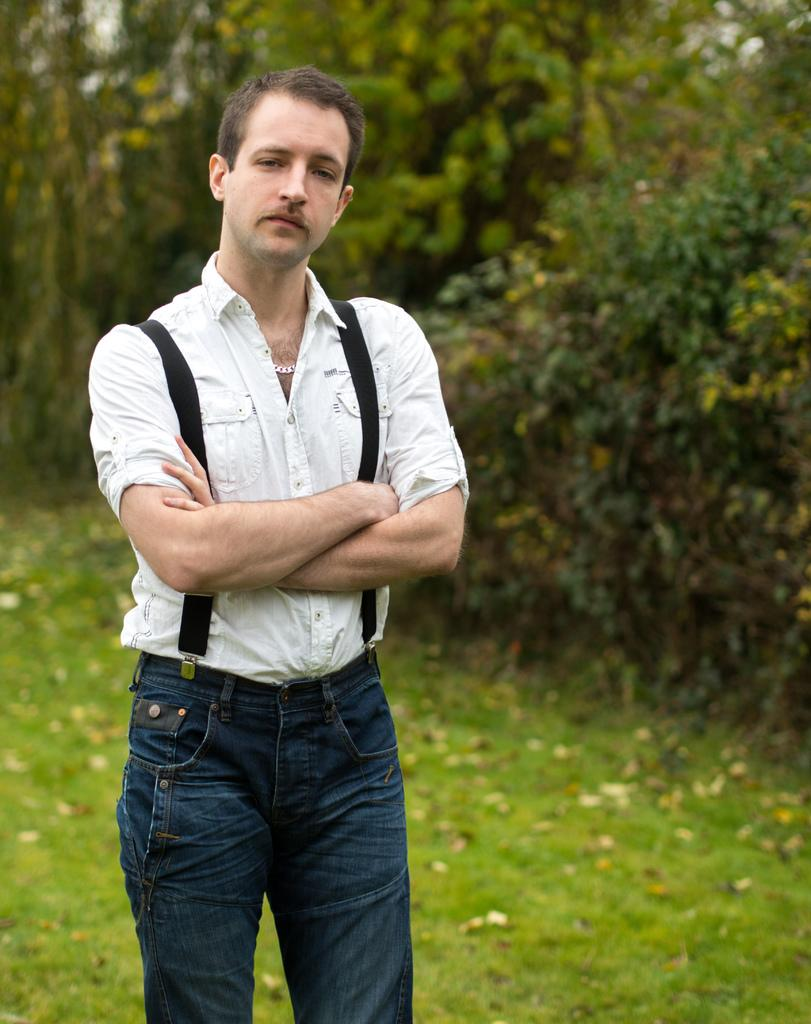What is the main subject of the image? There is a person standing in the center of the image. What can be seen in the background of the image? There are trees and grass in the background of the image. What type of force is being applied to the person in the image? There is no indication of any force being applied to the person in the image. Can you tell me where the mailbox is located in the image? There is no mailbox present in the image. 